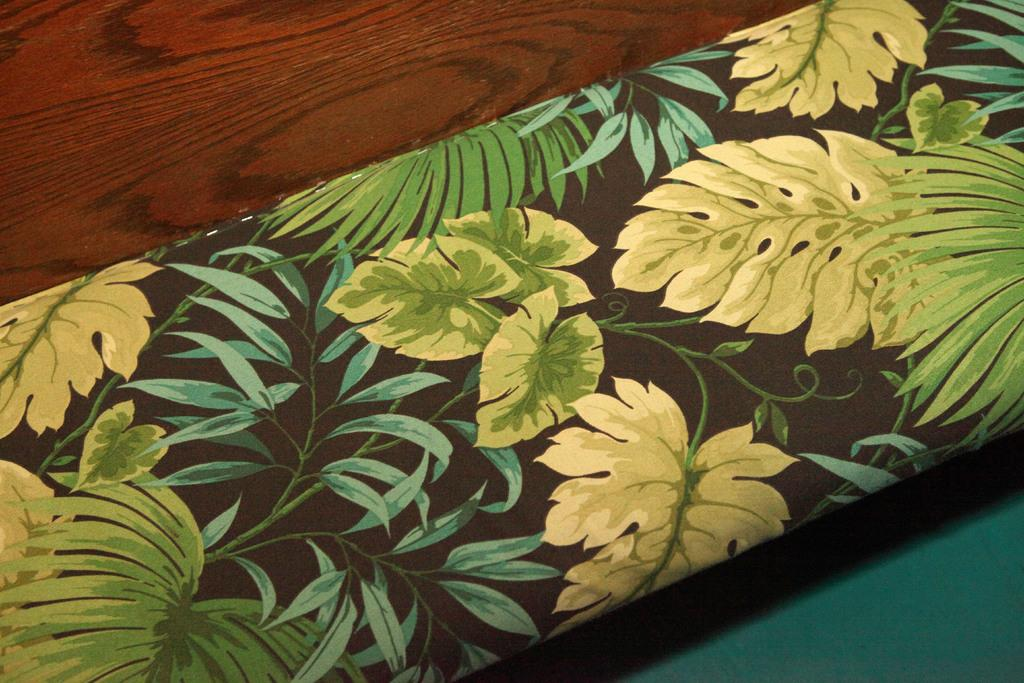What is the main subject of the image? There is a painting in the image. What is depicted in the painting? The painting depicts leaves. What is the painting mounted on? The painting is on a wooden plank. Can you see a duck in the painting? There is no duck present in the painting; it depicts leaves. Is there a cord attached to the wooden plank? There is no mention of a cord in the provided facts, so we cannot determine if one is present. 